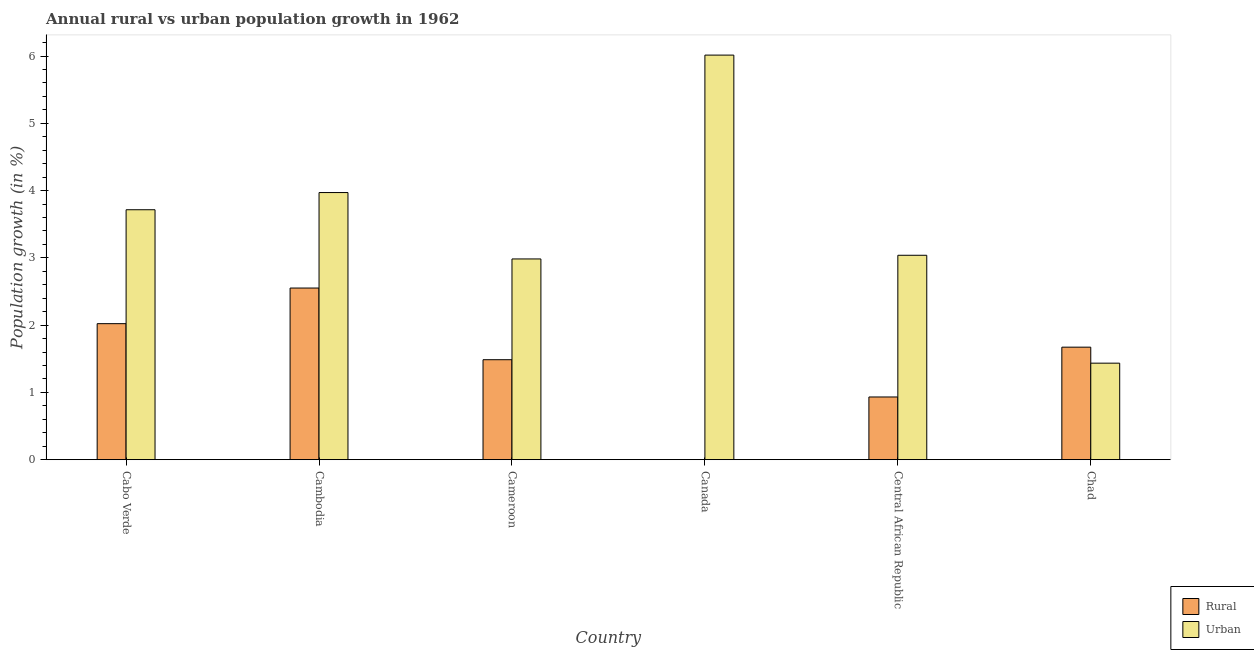How many different coloured bars are there?
Your response must be concise. 2. Are the number of bars per tick equal to the number of legend labels?
Provide a succinct answer. No. What is the label of the 6th group of bars from the left?
Your response must be concise. Chad. What is the urban population growth in Cambodia?
Your answer should be very brief. 3.97. Across all countries, what is the maximum urban population growth?
Offer a very short reply. 6.01. Across all countries, what is the minimum urban population growth?
Give a very brief answer. 1.43. What is the total rural population growth in the graph?
Provide a succinct answer. 8.66. What is the difference between the urban population growth in Cambodia and that in Central African Republic?
Keep it short and to the point. 0.93. What is the difference between the rural population growth in Cambodia and the urban population growth in Cameroon?
Offer a very short reply. -0.43. What is the average urban population growth per country?
Provide a succinct answer. 3.53. What is the difference between the urban population growth and rural population growth in Chad?
Make the answer very short. -0.24. In how many countries, is the rural population growth greater than 1.2 %?
Offer a very short reply. 4. What is the ratio of the urban population growth in Central African Republic to that in Chad?
Keep it short and to the point. 2.12. Is the difference between the urban population growth in Cabo Verde and Cameroon greater than the difference between the rural population growth in Cabo Verde and Cameroon?
Offer a terse response. Yes. What is the difference between the highest and the second highest rural population growth?
Make the answer very short. 0.53. What is the difference between the highest and the lowest urban population growth?
Keep it short and to the point. 4.58. Is the sum of the urban population growth in Canada and Central African Republic greater than the maximum rural population growth across all countries?
Your response must be concise. Yes. How many bars are there?
Your answer should be very brief. 11. Are all the bars in the graph horizontal?
Make the answer very short. No. Are the values on the major ticks of Y-axis written in scientific E-notation?
Provide a succinct answer. No. Does the graph contain grids?
Your answer should be very brief. No. How are the legend labels stacked?
Your answer should be very brief. Vertical. What is the title of the graph?
Keep it short and to the point. Annual rural vs urban population growth in 1962. What is the label or title of the Y-axis?
Offer a terse response. Population growth (in %). What is the Population growth (in %) in Rural in Cabo Verde?
Your response must be concise. 2.02. What is the Population growth (in %) of Urban  in Cabo Verde?
Make the answer very short. 3.72. What is the Population growth (in %) in Rural in Cambodia?
Offer a very short reply. 2.55. What is the Population growth (in %) in Urban  in Cambodia?
Your answer should be compact. 3.97. What is the Population growth (in %) in Rural in Cameroon?
Ensure brevity in your answer.  1.49. What is the Population growth (in %) in Urban  in Cameroon?
Your answer should be compact. 2.98. What is the Population growth (in %) in Rural in Canada?
Your answer should be compact. 0. What is the Population growth (in %) in Urban  in Canada?
Offer a terse response. 6.01. What is the Population growth (in %) in Rural in Central African Republic?
Offer a terse response. 0.93. What is the Population growth (in %) in Urban  in Central African Republic?
Provide a short and direct response. 3.04. What is the Population growth (in %) of Rural in Chad?
Make the answer very short. 1.67. What is the Population growth (in %) in Urban  in Chad?
Ensure brevity in your answer.  1.43. Across all countries, what is the maximum Population growth (in %) of Rural?
Provide a short and direct response. 2.55. Across all countries, what is the maximum Population growth (in %) of Urban ?
Provide a short and direct response. 6.01. Across all countries, what is the minimum Population growth (in %) of Urban ?
Offer a terse response. 1.43. What is the total Population growth (in %) of Rural in the graph?
Offer a terse response. 8.66. What is the total Population growth (in %) of Urban  in the graph?
Make the answer very short. 21.16. What is the difference between the Population growth (in %) in Rural in Cabo Verde and that in Cambodia?
Provide a short and direct response. -0.53. What is the difference between the Population growth (in %) of Urban  in Cabo Verde and that in Cambodia?
Offer a very short reply. -0.26. What is the difference between the Population growth (in %) in Rural in Cabo Verde and that in Cameroon?
Ensure brevity in your answer.  0.54. What is the difference between the Population growth (in %) of Urban  in Cabo Verde and that in Cameroon?
Ensure brevity in your answer.  0.73. What is the difference between the Population growth (in %) in Urban  in Cabo Verde and that in Canada?
Your answer should be very brief. -2.3. What is the difference between the Population growth (in %) of Rural in Cabo Verde and that in Central African Republic?
Make the answer very short. 1.09. What is the difference between the Population growth (in %) of Urban  in Cabo Verde and that in Central African Republic?
Keep it short and to the point. 0.68. What is the difference between the Population growth (in %) in Rural in Cabo Verde and that in Chad?
Make the answer very short. 0.35. What is the difference between the Population growth (in %) in Urban  in Cabo Verde and that in Chad?
Give a very brief answer. 2.28. What is the difference between the Population growth (in %) in Rural in Cambodia and that in Cameroon?
Offer a very short reply. 1.07. What is the difference between the Population growth (in %) of Urban  in Cambodia and that in Canada?
Keep it short and to the point. -2.04. What is the difference between the Population growth (in %) in Rural in Cambodia and that in Central African Republic?
Provide a succinct answer. 1.62. What is the difference between the Population growth (in %) in Urban  in Cambodia and that in Central African Republic?
Ensure brevity in your answer.  0.93. What is the difference between the Population growth (in %) in Rural in Cambodia and that in Chad?
Make the answer very short. 0.88. What is the difference between the Population growth (in %) of Urban  in Cambodia and that in Chad?
Your response must be concise. 2.54. What is the difference between the Population growth (in %) in Urban  in Cameroon and that in Canada?
Your answer should be very brief. -3.03. What is the difference between the Population growth (in %) in Rural in Cameroon and that in Central African Republic?
Provide a short and direct response. 0.55. What is the difference between the Population growth (in %) of Urban  in Cameroon and that in Central African Republic?
Offer a terse response. -0.05. What is the difference between the Population growth (in %) of Rural in Cameroon and that in Chad?
Offer a terse response. -0.19. What is the difference between the Population growth (in %) of Urban  in Cameroon and that in Chad?
Provide a succinct answer. 1.55. What is the difference between the Population growth (in %) in Urban  in Canada and that in Central African Republic?
Make the answer very short. 2.98. What is the difference between the Population growth (in %) in Urban  in Canada and that in Chad?
Offer a very short reply. 4.58. What is the difference between the Population growth (in %) of Rural in Central African Republic and that in Chad?
Keep it short and to the point. -0.74. What is the difference between the Population growth (in %) of Urban  in Central African Republic and that in Chad?
Ensure brevity in your answer.  1.6. What is the difference between the Population growth (in %) of Rural in Cabo Verde and the Population growth (in %) of Urban  in Cambodia?
Give a very brief answer. -1.95. What is the difference between the Population growth (in %) of Rural in Cabo Verde and the Population growth (in %) of Urban  in Cameroon?
Give a very brief answer. -0.96. What is the difference between the Population growth (in %) in Rural in Cabo Verde and the Population growth (in %) in Urban  in Canada?
Keep it short and to the point. -3.99. What is the difference between the Population growth (in %) in Rural in Cabo Verde and the Population growth (in %) in Urban  in Central African Republic?
Ensure brevity in your answer.  -1.02. What is the difference between the Population growth (in %) in Rural in Cabo Verde and the Population growth (in %) in Urban  in Chad?
Offer a very short reply. 0.59. What is the difference between the Population growth (in %) of Rural in Cambodia and the Population growth (in %) of Urban  in Cameroon?
Provide a short and direct response. -0.43. What is the difference between the Population growth (in %) of Rural in Cambodia and the Population growth (in %) of Urban  in Canada?
Ensure brevity in your answer.  -3.46. What is the difference between the Population growth (in %) in Rural in Cambodia and the Population growth (in %) in Urban  in Central African Republic?
Your answer should be compact. -0.49. What is the difference between the Population growth (in %) in Rural in Cambodia and the Population growth (in %) in Urban  in Chad?
Offer a very short reply. 1.12. What is the difference between the Population growth (in %) in Rural in Cameroon and the Population growth (in %) in Urban  in Canada?
Offer a terse response. -4.53. What is the difference between the Population growth (in %) in Rural in Cameroon and the Population growth (in %) in Urban  in Central African Republic?
Offer a very short reply. -1.55. What is the difference between the Population growth (in %) of Rural in Cameroon and the Population growth (in %) of Urban  in Chad?
Your answer should be compact. 0.05. What is the difference between the Population growth (in %) of Rural in Central African Republic and the Population growth (in %) of Urban  in Chad?
Keep it short and to the point. -0.5. What is the average Population growth (in %) in Rural per country?
Keep it short and to the point. 1.44. What is the average Population growth (in %) in Urban  per country?
Provide a short and direct response. 3.53. What is the difference between the Population growth (in %) of Rural and Population growth (in %) of Urban  in Cabo Verde?
Your answer should be very brief. -1.69. What is the difference between the Population growth (in %) of Rural and Population growth (in %) of Urban  in Cambodia?
Your answer should be compact. -1.42. What is the difference between the Population growth (in %) of Rural and Population growth (in %) of Urban  in Cameroon?
Keep it short and to the point. -1.5. What is the difference between the Population growth (in %) in Rural and Population growth (in %) in Urban  in Central African Republic?
Ensure brevity in your answer.  -2.11. What is the difference between the Population growth (in %) of Rural and Population growth (in %) of Urban  in Chad?
Provide a succinct answer. 0.24. What is the ratio of the Population growth (in %) of Rural in Cabo Verde to that in Cambodia?
Provide a succinct answer. 0.79. What is the ratio of the Population growth (in %) in Urban  in Cabo Verde to that in Cambodia?
Your answer should be very brief. 0.94. What is the ratio of the Population growth (in %) in Rural in Cabo Verde to that in Cameroon?
Keep it short and to the point. 1.36. What is the ratio of the Population growth (in %) of Urban  in Cabo Verde to that in Cameroon?
Keep it short and to the point. 1.25. What is the ratio of the Population growth (in %) in Urban  in Cabo Verde to that in Canada?
Offer a very short reply. 0.62. What is the ratio of the Population growth (in %) in Rural in Cabo Verde to that in Central African Republic?
Your answer should be compact. 2.17. What is the ratio of the Population growth (in %) in Urban  in Cabo Verde to that in Central African Republic?
Give a very brief answer. 1.22. What is the ratio of the Population growth (in %) in Rural in Cabo Verde to that in Chad?
Your response must be concise. 1.21. What is the ratio of the Population growth (in %) of Urban  in Cabo Verde to that in Chad?
Make the answer very short. 2.59. What is the ratio of the Population growth (in %) in Rural in Cambodia to that in Cameroon?
Your answer should be compact. 1.72. What is the ratio of the Population growth (in %) of Urban  in Cambodia to that in Cameroon?
Your response must be concise. 1.33. What is the ratio of the Population growth (in %) in Urban  in Cambodia to that in Canada?
Offer a very short reply. 0.66. What is the ratio of the Population growth (in %) of Rural in Cambodia to that in Central African Republic?
Make the answer very short. 2.74. What is the ratio of the Population growth (in %) of Urban  in Cambodia to that in Central African Republic?
Ensure brevity in your answer.  1.31. What is the ratio of the Population growth (in %) of Rural in Cambodia to that in Chad?
Your answer should be compact. 1.53. What is the ratio of the Population growth (in %) in Urban  in Cambodia to that in Chad?
Provide a short and direct response. 2.77. What is the ratio of the Population growth (in %) in Urban  in Cameroon to that in Canada?
Give a very brief answer. 0.5. What is the ratio of the Population growth (in %) of Rural in Cameroon to that in Central African Republic?
Offer a very short reply. 1.59. What is the ratio of the Population growth (in %) of Urban  in Cameroon to that in Central African Republic?
Provide a succinct answer. 0.98. What is the ratio of the Population growth (in %) of Rural in Cameroon to that in Chad?
Offer a terse response. 0.89. What is the ratio of the Population growth (in %) in Urban  in Cameroon to that in Chad?
Provide a short and direct response. 2.08. What is the ratio of the Population growth (in %) in Urban  in Canada to that in Central African Republic?
Give a very brief answer. 1.98. What is the ratio of the Population growth (in %) of Urban  in Canada to that in Chad?
Offer a terse response. 4.19. What is the ratio of the Population growth (in %) in Rural in Central African Republic to that in Chad?
Offer a very short reply. 0.56. What is the ratio of the Population growth (in %) in Urban  in Central African Republic to that in Chad?
Your answer should be very brief. 2.12. What is the difference between the highest and the second highest Population growth (in %) in Rural?
Keep it short and to the point. 0.53. What is the difference between the highest and the second highest Population growth (in %) in Urban ?
Keep it short and to the point. 2.04. What is the difference between the highest and the lowest Population growth (in %) of Rural?
Offer a terse response. 2.55. What is the difference between the highest and the lowest Population growth (in %) in Urban ?
Ensure brevity in your answer.  4.58. 